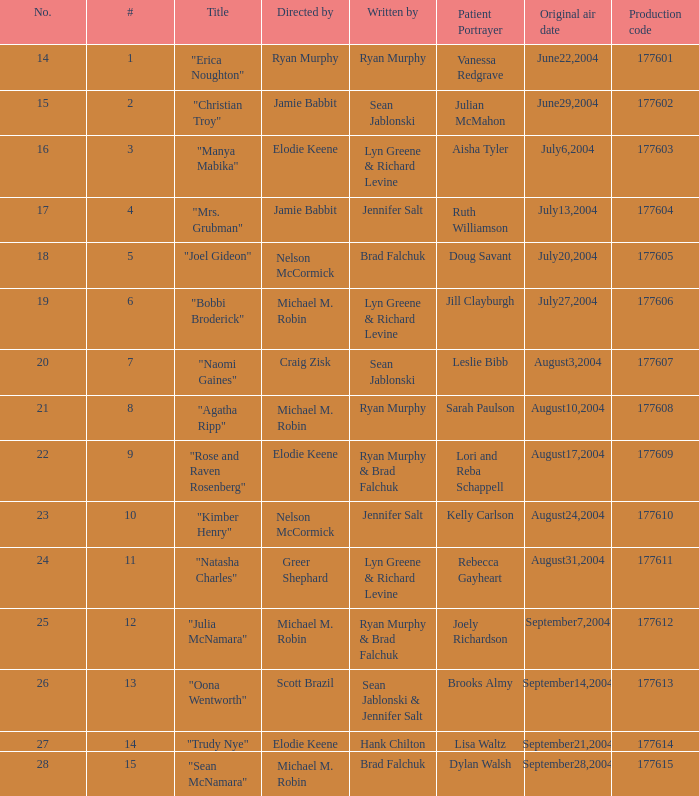What is the highest numbered episode with patient portrayer doug savant? 5.0. 